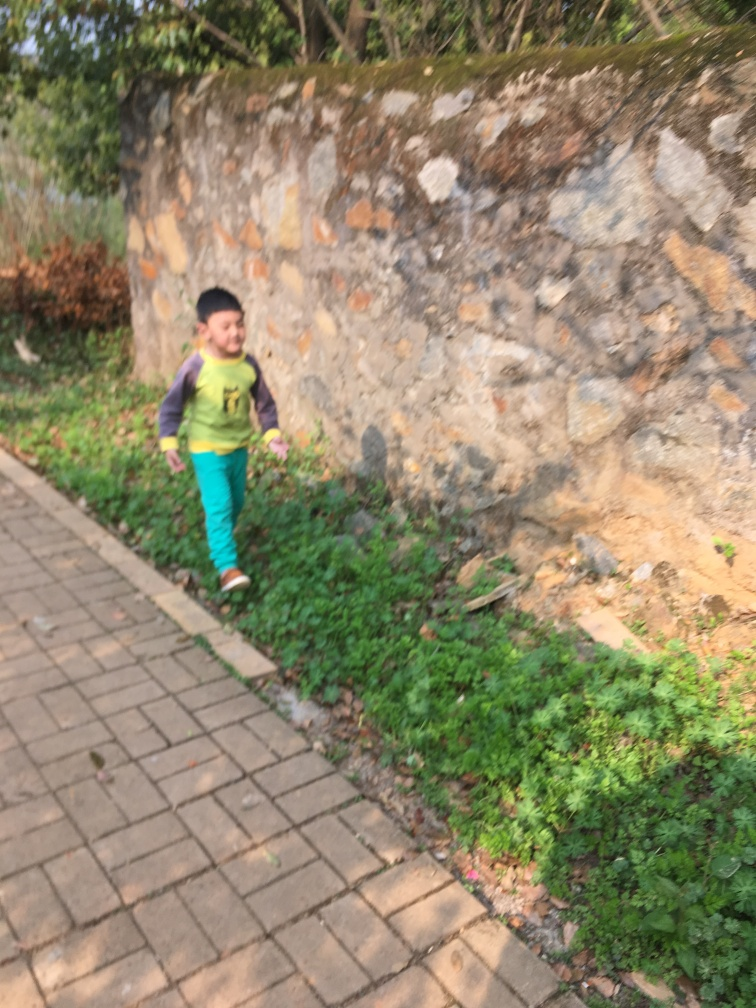Are there any quality issues with this image? The image appears to be slightly blurred, particularly around the moving subject, which suggests motion blur due to the subject's speed or camera movement. Additionally, the photo is not well-framed, cutting off the feet of the subject. The lighting is generally adequate, though there are some overexposed areas on the wall that could be distracting. 